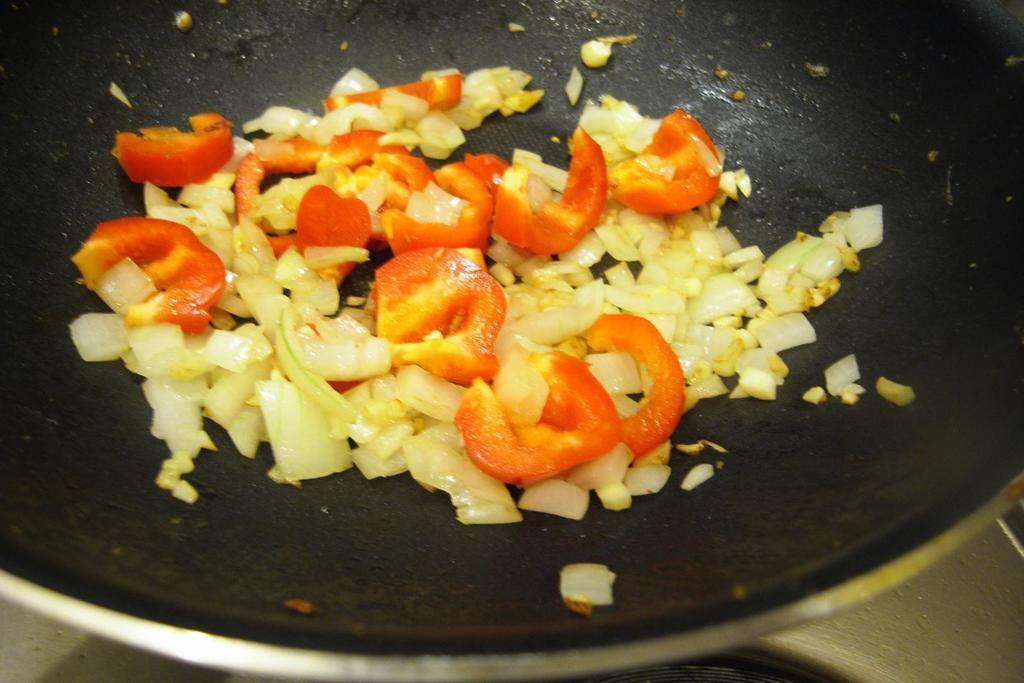How would you summarize this image in a sentence or two? In this picture we can see some vegetable like tomato and cabbage is placed on the black fry pan. 